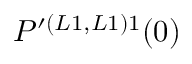Convert formula to latex. <formula><loc_0><loc_0><loc_500><loc_500>P ^ { \prime ( L 1 , L 1 ) 1 } ( 0 )</formula> 